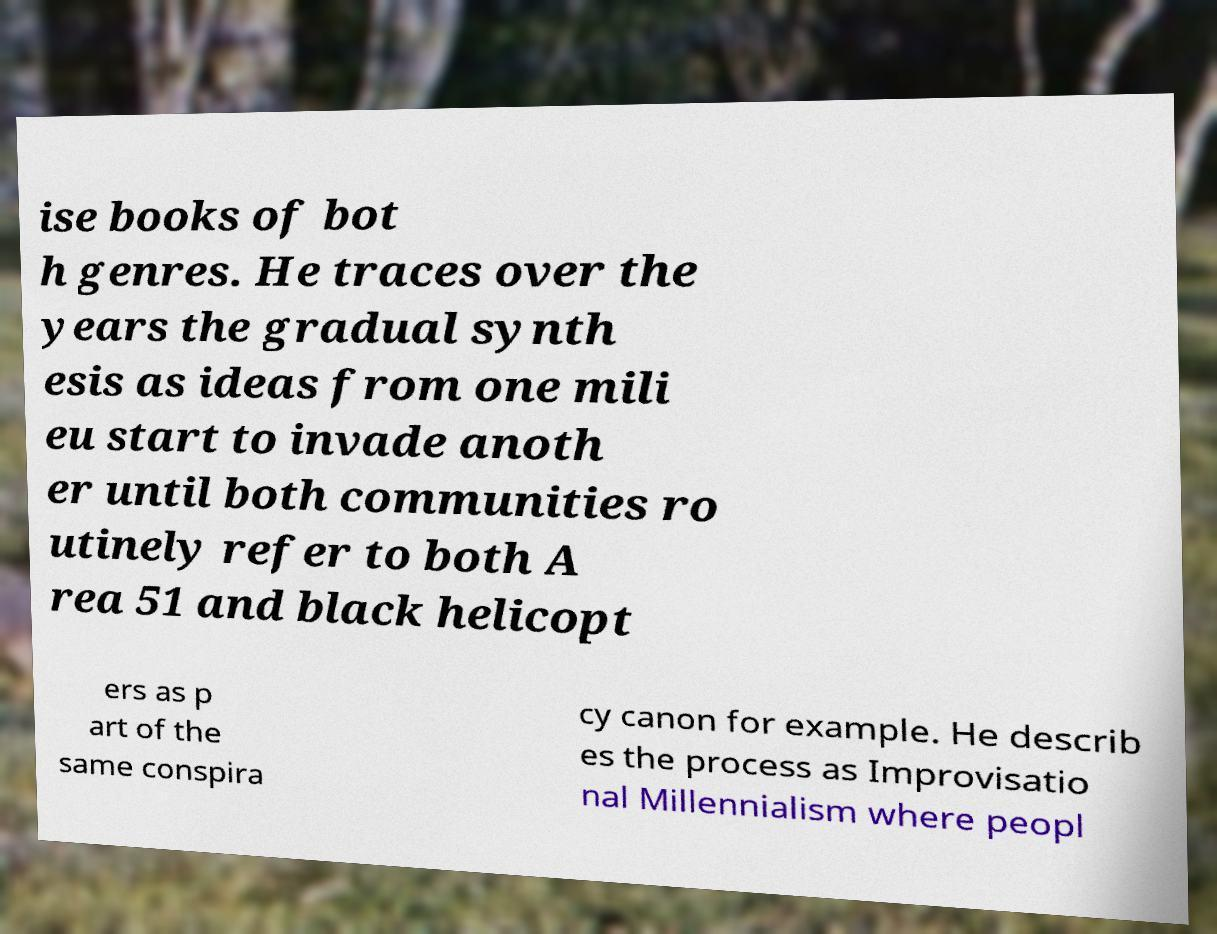Can you accurately transcribe the text from the provided image for me? ise books of bot h genres. He traces over the years the gradual synth esis as ideas from one mili eu start to invade anoth er until both communities ro utinely refer to both A rea 51 and black helicopt ers as p art of the same conspira cy canon for example. He describ es the process as Improvisatio nal Millennialism where peopl 